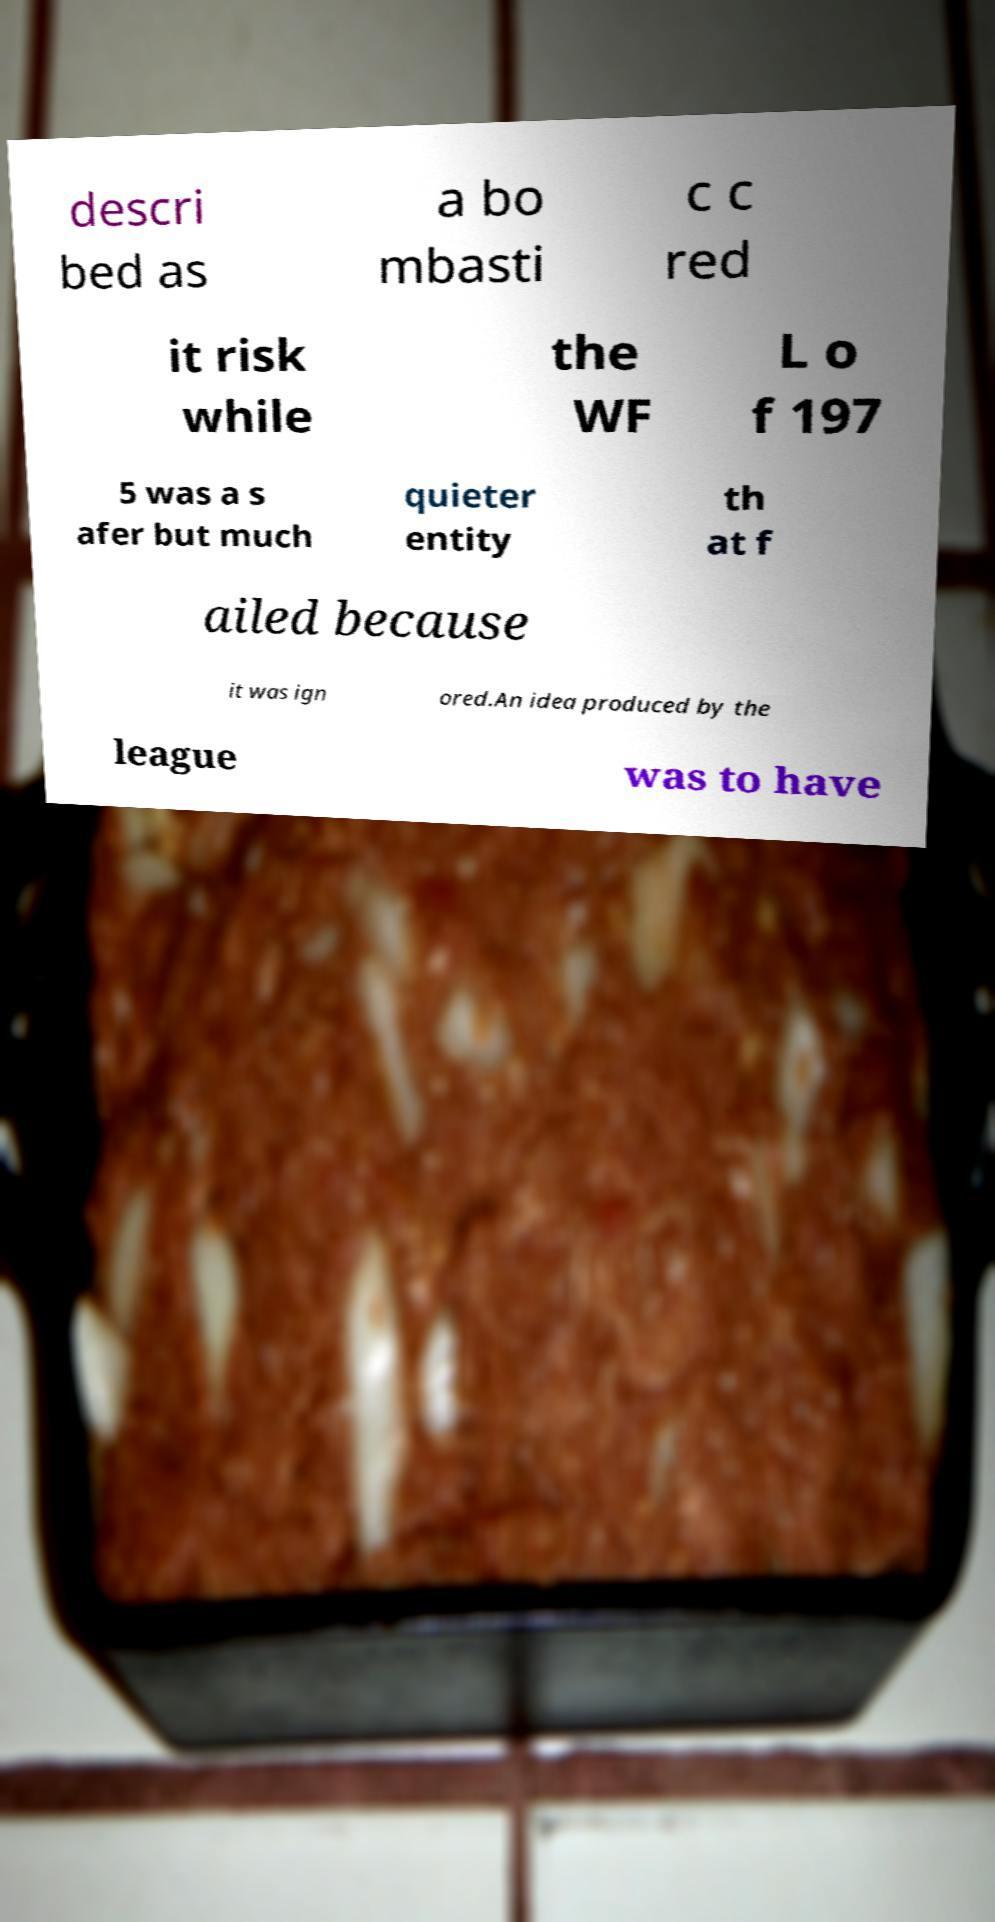Could you extract and type out the text from this image? descri bed as a bo mbasti c c red it risk while the WF L o f 197 5 was a s afer but much quieter entity th at f ailed because it was ign ored.An idea produced by the league was to have 